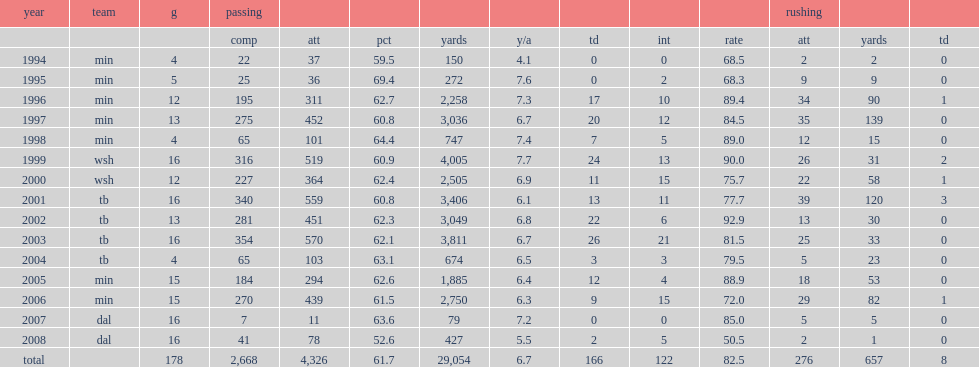How many passing touchdowns did brad johnson get in 2002? 22.0. Can you parse all the data within this table? {'header': ['year', 'team', 'g', 'passing', '', '', '', '', '', '', '', 'rushing', '', ''], 'rows': [['', '', '', 'comp', 'att', 'pct', 'yards', 'y/a', 'td', 'int', 'rate', 'att', 'yards', 'td'], ['1994', 'min', '4', '22', '37', '59.5', '150', '4.1', '0', '0', '68.5', '2', '2', '0'], ['1995', 'min', '5', '25', '36', '69.4', '272', '7.6', '0', '2', '68.3', '9', '9', '0'], ['1996', 'min', '12', '195', '311', '62.7', '2,258', '7.3', '17', '10', '89.4', '34', '90', '1'], ['1997', 'min', '13', '275', '452', '60.8', '3,036', '6.7', '20', '12', '84.5', '35', '139', '0'], ['1998', 'min', '4', '65', '101', '64.4', '747', '7.4', '7', '5', '89.0', '12', '15', '0'], ['1999', 'wsh', '16', '316', '519', '60.9', '4,005', '7.7', '24', '13', '90.0', '26', '31', '2'], ['2000', 'wsh', '12', '227', '364', '62.4', '2,505', '6.9', '11', '15', '75.7', '22', '58', '1'], ['2001', 'tb', '16', '340', '559', '60.8', '3,406', '6.1', '13', '11', '77.7', '39', '120', '3'], ['2002', 'tb', '13', '281', '451', '62.3', '3,049', '6.8', '22', '6', '92.9', '13', '30', '0'], ['2003', 'tb', '16', '354', '570', '62.1', '3,811', '6.7', '26', '21', '81.5', '25', '33', '0'], ['2004', 'tb', '4', '65', '103', '63.1', '674', '6.5', '3', '3', '79.5', '5', '23', '0'], ['2005', 'min', '15', '184', '294', '62.6', '1,885', '6.4', '12', '4', '88.9', '18', '53', '0'], ['2006', 'min', '15', '270', '439', '61.5', '2,750', '6.3', '9', '15', '72.0', '29', '82', '1'], ['2007', 'dal', '16', '7', '11', '63.6', '79', '7.2', '0', '0', '85.0', '5', '5', '0'], ['2008', 'dal', '16', '41', '78', '52.6', '427', '5.5', '2', '5', '50.5', '2', '1', '0'], ['total', '', '178', '2,668', '4,326', '61.7', '29,054', '6.7', '166', '122', '82.5', '276', '657', '8']]} 